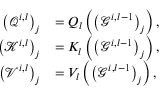<formula> <loc_0><loc_0><loc_500><loc_500>\begin{array} { r l } { \left ( \mathcal { Q } ^ { i , l } \right ) _ { j } } & { = Q _ { l } \left ( \left ( \mathcal { G } ^ { i , l - 1 } \right ) _ { j } \right ) , } \\ { \left ( \mathcal { K } ^ { i , l } \right ) _ { j } } & { = K _ { l } \left ( \left ( \mathcal { G } ^ { i , l - 1 } \right ) _ { j } \right ) , } \\ { \left ( \mathcal { V } ^ { i , l } \right ) _ { j } } & { = V _ { l } \left ( \left ( \mathcal { G } ^ { i , l - 1 } \right ) _ { j } \right ) , } \end{array}</formula> 